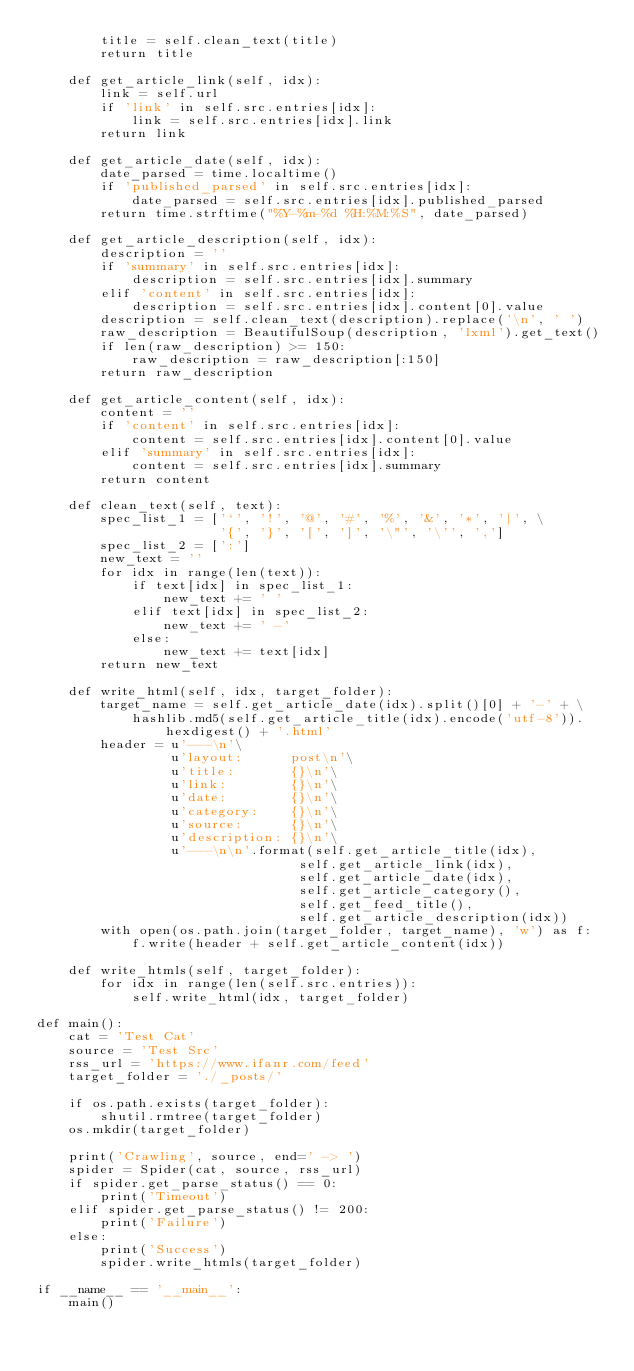Convert code to text. <code><loc_0><loc_0><loc_500><loc_500><_Python_>		title = self.clean_text(title)
		return title

	def get_article_link(self, idx):
		link = self.url
		if 'link' in self.src.entries[idx]:
			link = self.src.entries[idx].link
		return link

	def get_article_date(self, idx):
		date_parsed = time.localtime()
		if 'published_parsed' in self.src.entries[idx]:
			date_parsed = self.src.entries[idx].published_parsed
		return time.strftime("%Y-%m-%d %H:%M:%S", date_parsed)

	def get_article_description(self, idx):
		description = ''
		if 'summary' in self.src.entries[idx]:
			description = self.src.entries[idx].summary
		elif 'content' in self.src.entries[idx]:
			description = self.src.entries[idx].content[0].value
		description = self.clean_text(description).replace('\n', ' ')
		raw_description = BeautifulSoup(description, 'lxml').get_text()
		if len(raw_description) >= 150:
			raw_description = raw_description[:150]
		return raw_description

	def get_article_content(self, idx):
		content = ''
		if 'content' in self.src.entries[idx]:
			content = self.src.entries[idx].content[0].value
		elif 'summary' in self.src.entries[idx]:
			content = self.src.entries[idx].summary
		return content

	def clean_text(self, text):
		spec_list_1 = ['`', '!', '@', '#', '%', '&', '*', '|', \
					   '{', '}', '[', ']', '\"', '\'', ',']
		spec_list_2 = [':']
		new_text = ''
		for idx in range(len(text)):
			if text[idx] in spec_list_1:
				new_text += ' '
			elif text[idx] in spec_list_2:
				new_text += ' -'
			else:
				new_text += text[idx]
		return new_text

	def write_html(self, idx, target_folder):
		target_name = self.get_article_date(idx).split()[0] + '-' + \
			hashlib.md5(self.get_article_title(idx).encode('utf-8')).hexdigest() + '.html'
		header = u'---\n'\
				 u'layout:      post\n'\
				 u'title:       {}\n'\
				 u'link:        {}\n'\
				 u'date:        {}\n'\
				 u'category:    {}\n'\
				 u'source:      {}\n'\
				 u'description: {}\n'\
				 u'---\n\n'.format(self.get_article_title(idx),
				  	          	 self.get_article_link(idx),
				  	          	 self.get_article_date(idx),
				  	          	 self.get_article_category(),
				  	          	 self.get_feed_title(),
				  	          	 self.get_article_description(idx))
		with open(os.path.join(target_folder, target_name), 'w') as f:
			f.write(header + self.get_article_content(idx))

	def write_htmls(self, target_folder):
		for idx in range(len(self.src.entries)):
			self.write_html(idx, target_folder)

def main():
	cat = 'Test Cat'
	source = 'Test Src'
	rss_url = 'https://www.ifanr.com/feed'
	target_folder = './_posts/'

	if os.path.exists(target_folder):
		shutil.rmtree(target_folder)
	os.mkdir(target_folder)

	print('Crawling', source, end=' -> ')
	spider = Spider(cat, source, rss_url)
	if spider.get_parse_status() == 0:
		print('Timeout')
	elif spider.get_parse_status() != 200:
		print('Failure')
	else:
		print('Success')
		spider.write_htmls(target_folder)

if __name__ == '__main__':
	main()</code> 